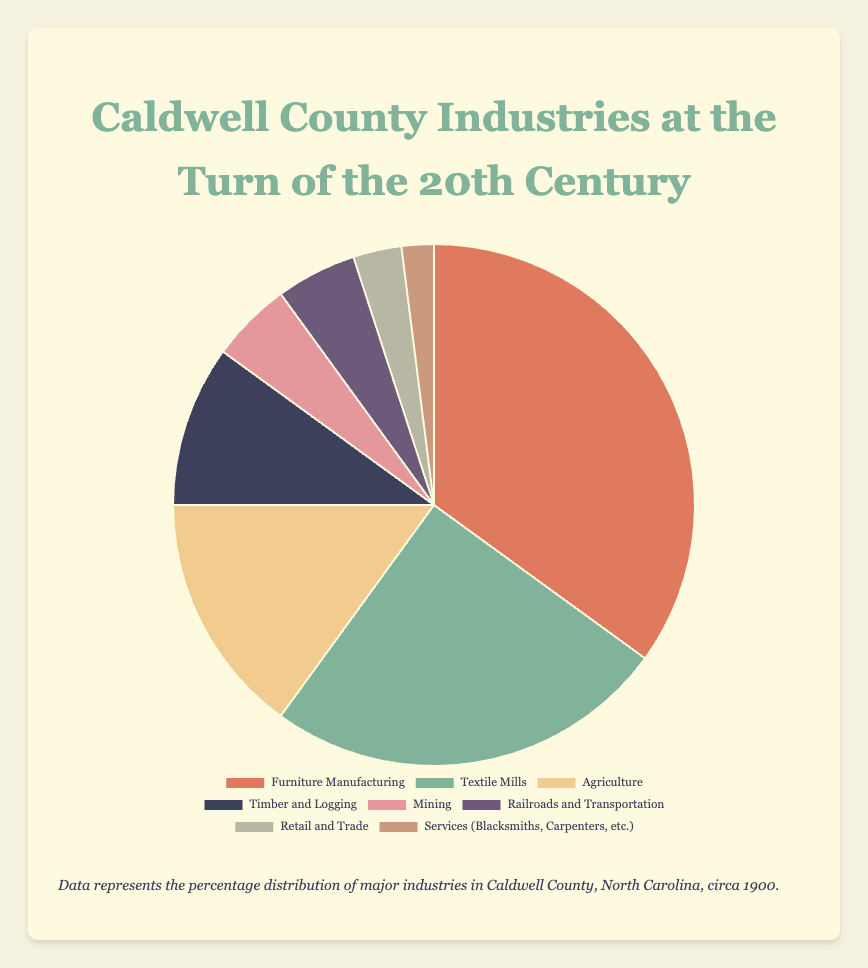Which industry has the largest representation in Caldwell County at the turn of the 20th century? From the pie chart, the largest segment represents "Furniture Manufacturing" with 35%.
Answer: Furniture Manufacturing What is the combined percentage of Textile Mills and Agriculture? Textile Mills account for 25% and Agriculture accounts for 15%. Adding these together, 25% + 15% = 40%.
Answer: 40% How does the percentage of Timber and Logging compare to the percentage of Mining? Timber and Logging is 10%, while Mining is 5%. So, Timber and Logging is twice the percentage of Mining.
Answer: Timber and Logging is 2 times greater What is the difference in percentage between the largest industry and the smallest industry? The largest industry is Furniture Manufacturing with 35%, and the smallest is Services (Blacksmiths, Carpenters, etc.) with 2%. The difference is 35% - 2% = 33%.
Answer: 33% How many industries have a representation of less than 10%? The chart shows that Timber and Logging (10%), Mining (5%), Railroads and Transportation (5%), Retail and Trade (3%), and Services (2%) all fall under 10%. There are 5 such industries.
Answer: 5 Which industry is represented by the green segment in the pie chart? By referring to the color scheme in the pie chart, the green segment corresponds to Textile Mills, which has a 25% representation.
Answer: Textile Mills What's the total percentage of industries related to transportation and services (Railroads and Transportation + Services)? Railroads and Transportation have 5% and Services (Blacksmiths, Carpenters, etc.) have 2%. Adding these gives 5% + 2% = 7%.
Answer: 7% Are there any industries that have an equal percentage representation? If so, which ones? Both Mining and Railroads and Transportation are represented with 5% each.
Answer: Mining and Railroads and Transportation Which segment is visually the smallest on the pie chart? The smallest segment, visually, is the one representing Services (Blacksmiths, Carpenters, etc.), with 2%.
Answer: Services (Blacksmiths, Carpenters, etc.) If you combine the percentages of all industries except Furniture Manufacturing, what is the total percentage? Summing up the percentages of the other industries: 25% (Textile Mills) + 15% (Agriculture) + 10% (Timber and Logging) + 5% (Mining) + 5% (Railroads and Transportation) + 3% (Retail and Trade) + 2% (Services) = 65%.
Answer: 65% 